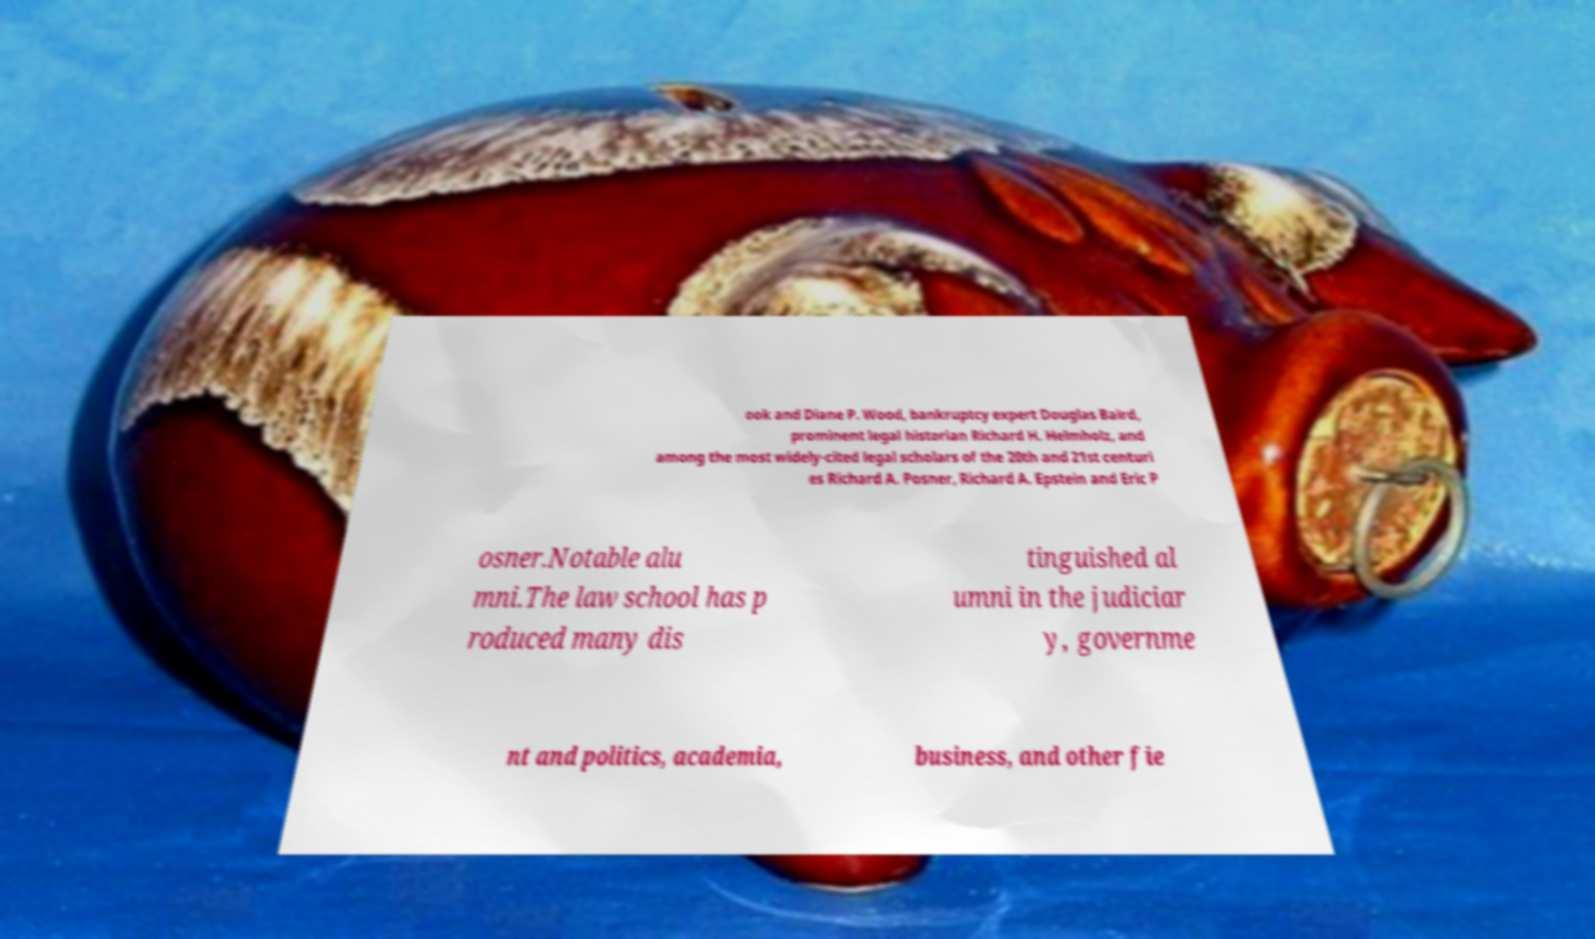Could you extract and type out the text from this image? ook and Diane P. Wood, bankruptcy expert Douglas Baird, prominent legal historian Richard H. Helmholz, and among the most widely-cited legal scholars of the 20th and 21st centuri es Richard A. Posner, Richard A. Epstein and Eric P osner.Notable alu mni.The law school has p roduced many dis tinguished al umni in the judiciar y, governme nt and politics, academia, business, and other fie 